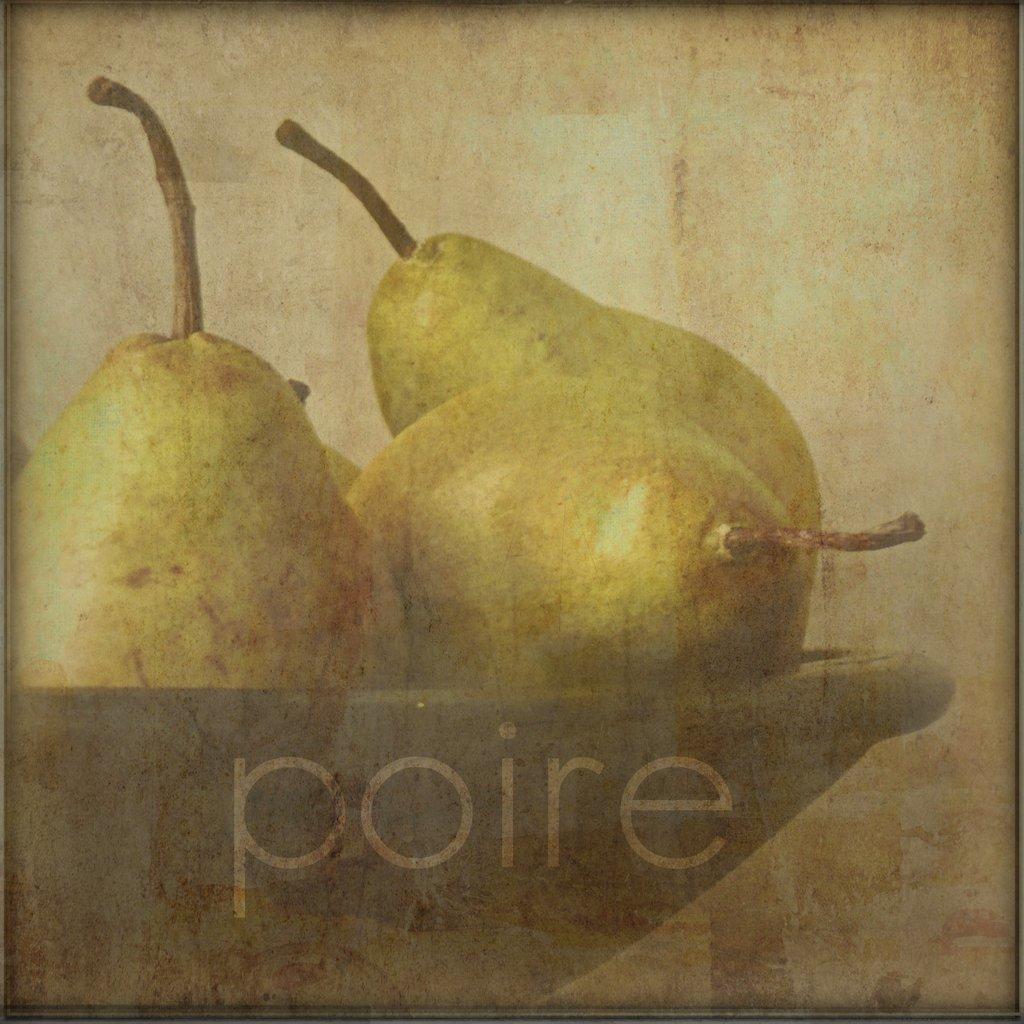Could you give a brief overview of what you see in this image? In this image we can see the picture of some pears in a bowl. We can also see some text on it. 